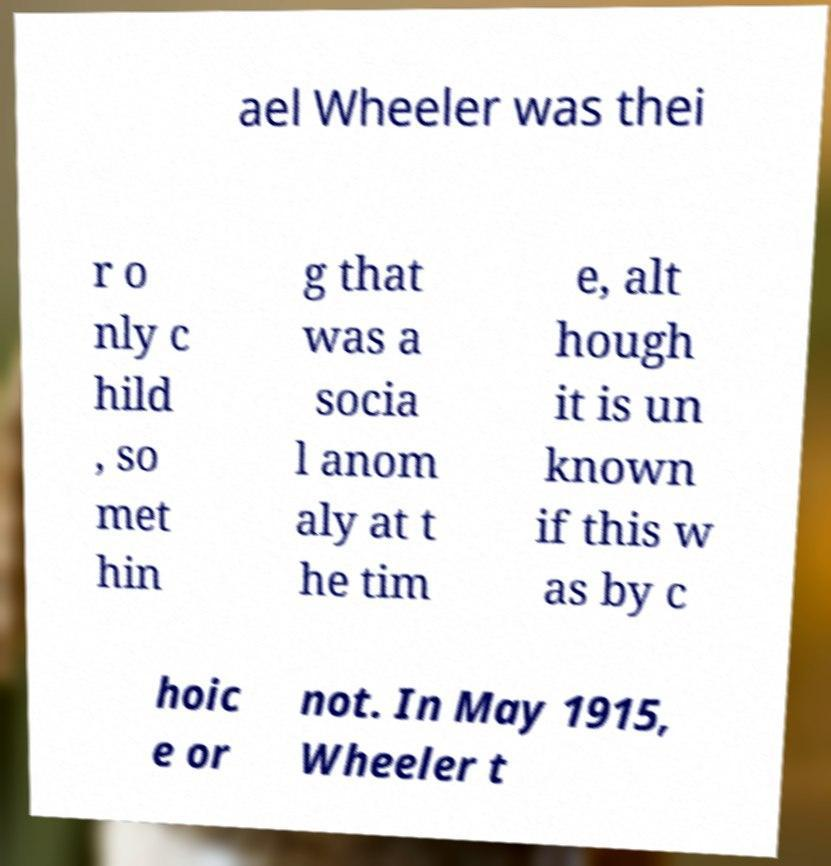Can you accurately transcribe the text from the provided image for me? ael Wheeler was thei r o nly c hild , so met hin g that was a socia l anom aly at t he tim e, alt hough it is un known if this w as by c hoic e or not. In May 1915, Wheeler t 